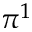Convert formula to latex. <formula><loc_0><loc_0><loc_500><loc_500>\pi ^ { 1 }</formula> 